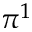Convert formula to latex. <formula><loc_0><loc_0><loc_500><loc_500>\pi ^ { 1 }</formula> 